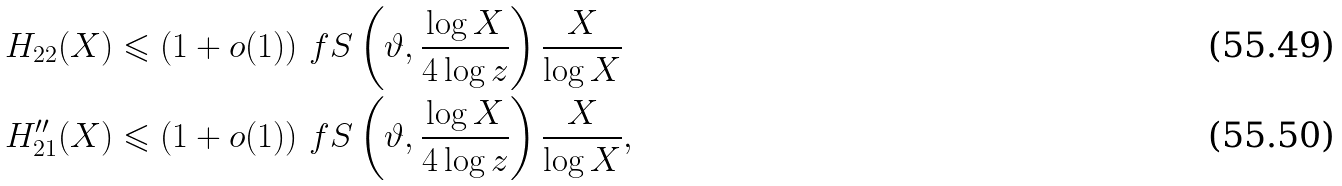<formula> <loc_0><loc_0><loc_500><loc_500>H _ { 2 2 } ( X ) & \leqslant ( 1 + o ( 1 ) ) \ f S \left ( \vartheta , \frac { \log X } { 4 \log z } \right ) \frac { X } { \log X } \\ H _ { 2 1 } ^ { \prime \prime } ( X ) & \leqslant ( 1 + o ( 1 ) ) \ f S \left ( \vartheta , \frac { \log X } { 4 \log z } \right ) \frac { X } { \log X } ,</formula> 